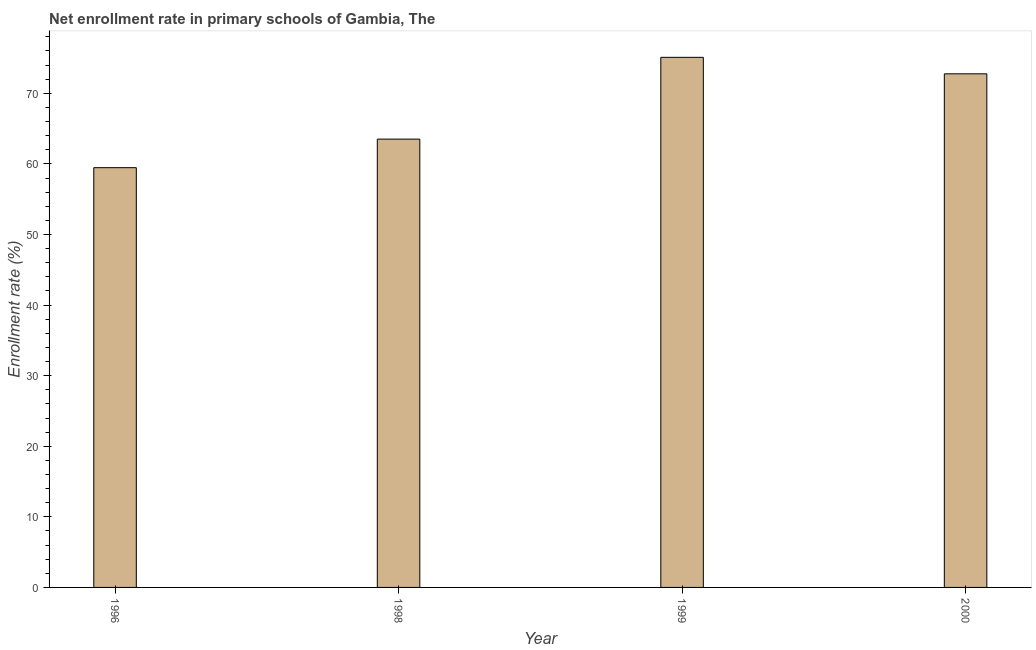Does the graph contain any zero values?
Your answer should be very brief. No. Does the graph contain grids?
Provide a short and direct response. No. What is the title of the graph?
Provide a short and direct response. Net enrollment rate in primary schools of Gambia, The. What is the label or title of the Y-axis?
Offer a terse response. Enrollment rate (%). What is the net enrollment rate in primary schools in 1999?
Make the answer very short. 75.1. Across all years, what is the maximum net enrollment rate in primary schools?
Offer a terse response. 75.1. Across all years, what is the minimum net enrollment rate in primary schools?
Offer a very short reply. 59.46. What is the sum of the net enrollment rate in primary schools?
Your answer should be very brief. 270.83. What is the difference between the net enrollment rate in primary schools in 1999 and 2000?
Give a very brief answer. 2.34. What is the average net enrollment rate in primary schools per year?
Offer a very short reply. 67.71. What is the median net enrollment rate in primary schools?
Make the answer very short. 68.13. What is the ratio of the net enrollment rate in primary schools in 1996 to that in 2000?
Your response must be concise. 0.82. Is the difference between the net enrollment rate in primary schools in 1998 and 2000 greater than the difference between any two years?
Offer a very short reply. No. What is the difference between the highest and the second highest net enrollment rate in primary schools?
Offer a very short reply. 2.34. Is the sum of the net enrollment rate in primary schools in 1998 and 1999 greater than the maximum net enrollment rate in primary schools across all years?
Keep it short and to the point. Yes. What is the difference between the highest and the lowest net enrollment rate in primary schools?
Give a very brief answer. 15.63. In how many years, is the net enrollment rate in primary schools greater than the average net enrollment rate in primary schools taken over all years?
Provide a short and direct response. 2. How many years are there in the graph?
Offer a very short reply. 4. What is the Enrollment rate (%) of 1996?
Your answer should be very brief. 59.46. What is the Enrollment rate (%) in 1998?
Make the answer very short. 63.51. What is the Enrollment rate (%) in 1999?
Ensure brevity in your answer.  75.1. What is the Enrollment rate (%) of 2000?
Your answer should be very brief. 72.76. What is the difference between the Enrollment rate (%) in 1996 and 1998?
Ensure brevity in your answer.  -4.05. What is the difference between the Enrollment rate (%) in 1996 and 1999?
Keep it short and to the point. -15.63. What is the difference between the Enrollment rate (%) in 1996 and 2000?
Provide a short and direct response. -13.29. What is the difference between the Enrollment rate (%) in 1998 and 1999?
Your answer should be compact. -11.59. What is the difference between the Enrollment rate (%) in 1998 and 2000?
Provide a short and direct response. -9.25. What is the difference between the Enrollment rate (%) in 1999 and 2000?
Keep it short and to the point. 2.34. What is the ratio of the Enrollment rate (%) in 1996 to that in 1998?
Provide a succinct answer. 0.94. What is the ratio of the Enrollment rate (%) in 1996 to that in 1999?
Ensure brevity in your answer.  0.79. What is the ratio of the Enrollment rate (%) in 1996 to that in 2000?
Your answer should be compact. 0.82. What is the ratio of the Enrollment rate (%) in 1998 to that in 1999?
Offer a very short reply. 0.85. What is the ratio of the Enrollment rate (%) in 1998 to that in 2000?
Your answer should be compact. 0.87. What is the ratio of the Enrollment rate (%) in 1999 to that in 2000?
Your response must be concise. 1.03. 